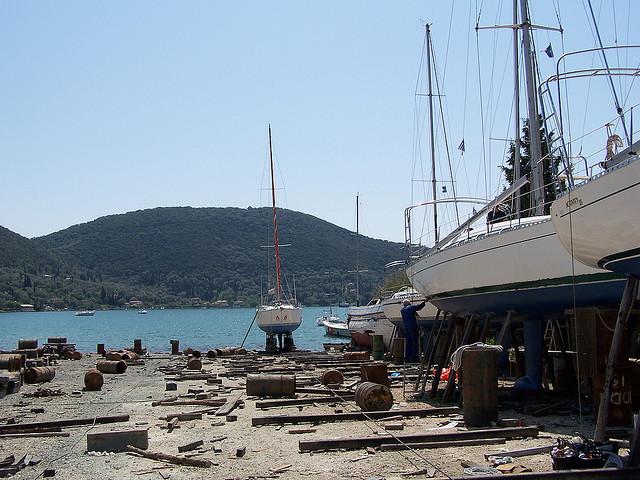How many mountains are pictured?
Be succinct. 2. Where is the smaller boat?
Answer briefly. On blocks. Does this yard look littered or clean?
Write a very short answer. Littered. What is the color of the sky?
Concise answer only. Blue. Where is the boat?
Concise answer only. Dock. 